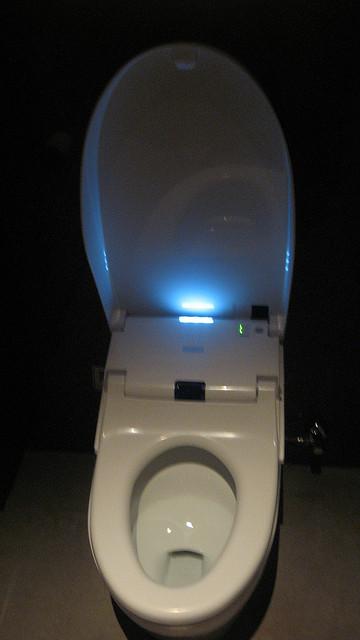How many lights are on this toilet?
Be succinct. 1. Are there instructions on the toilet lid?
Short answer required. No. Is this an electric toilet?
Short answer required. Yes. Is the toilet lid open?
Concise answer only. Yes. 